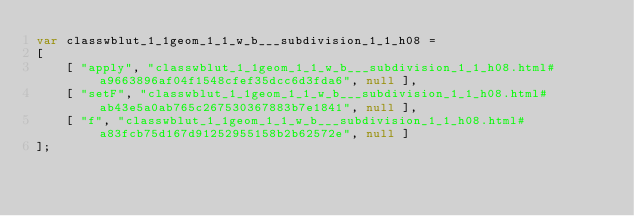Convert code to text. <code><loc_0><loc_0><loc_500><loc_500><_JavaScript_>var classwblut_1_1geom_1_1_w_b___subdivision_1_1_h08 =
[
    [ "apply", "classwblut_1_1geom_1_1_w_b___subdivision_1_1_h08.html#a9663896af04f1548cfef35dcc6d3fda6", null ],
    [ "setF", "classwblut_1_1geom_1_1_w_b___subdivision_1_1_h08.html#ab43e5a0ab765c267530367883b7e1841", null ],
    [ "f", "classwblut_1_1geom_1_1_w_b___subdivision_1_1_h08.html#a83fcb75d167d91252955158b2b62572e", null ]
];</code> 